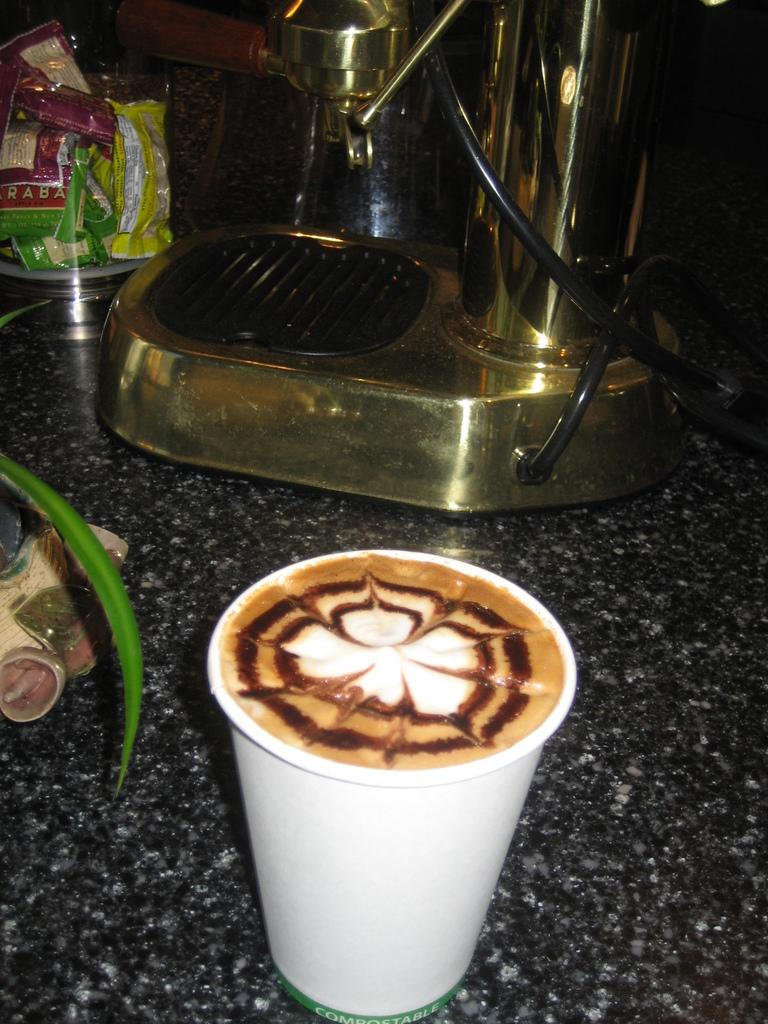What is in the cup that is visible in the image? There is a cup of coffee in the image. What else can be seen in the image besides the cup of coffee? There is a machine in the image. What type of goat can be seen climbing on the machine in the image? There is no goat present in the image; it only features a cup of coffee and a machine. Are there any cobwebs visible on the machine in the image? The image does not provide information about the presence of cobwebs on the machine. 